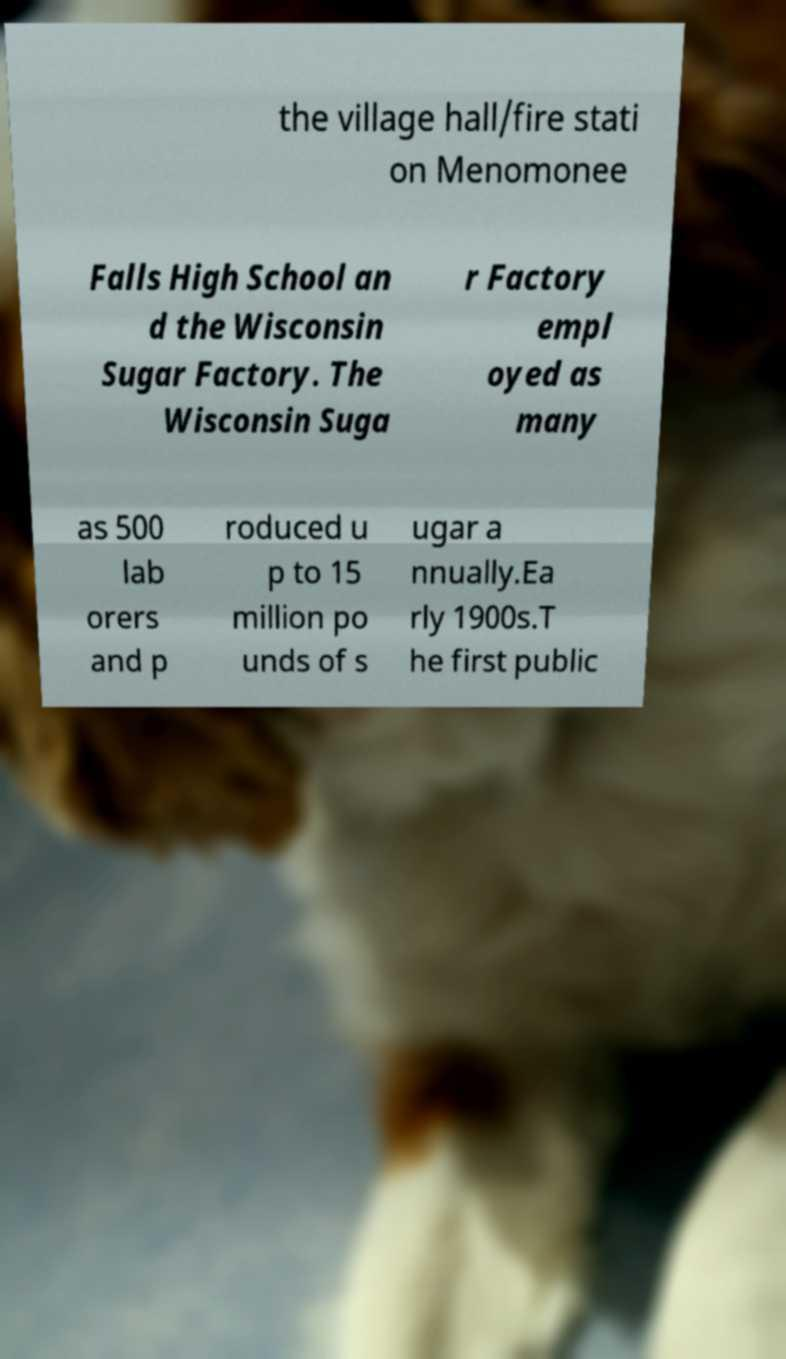There's text embedded in this image that I need extracted. Can you transcribe it verbatim? the village hall/fire stati on Menomonee Falls High School an d the Wisconsin Sugar Factory. The Wisconsin Suga r Factory empl oyed as many as 500 lab orers and p roduced u p to 15 million po unds of s ugar a nnually.Ea rly 1900s.T he first public 